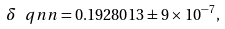<formula> <loc_0><loc_0><loc_500><loc_500>\delta _ { \ } q n n = 0 . 1 9 2 8 0 1 3 \pm 9 \times 1 0 ^ { - 7 } ,</formula> 